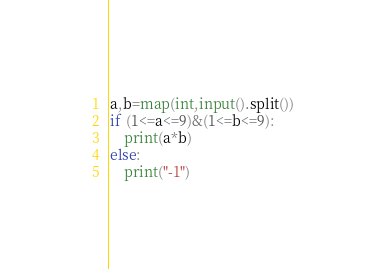Convert code to text. <code><loc_0><loc_0><loc_500><loc_500><_Python_>a,b=map(int,input().split())
if (1<=a<=9)&(1<=b<=9):
    print(a*b)
else:
    print("-1")</code> 